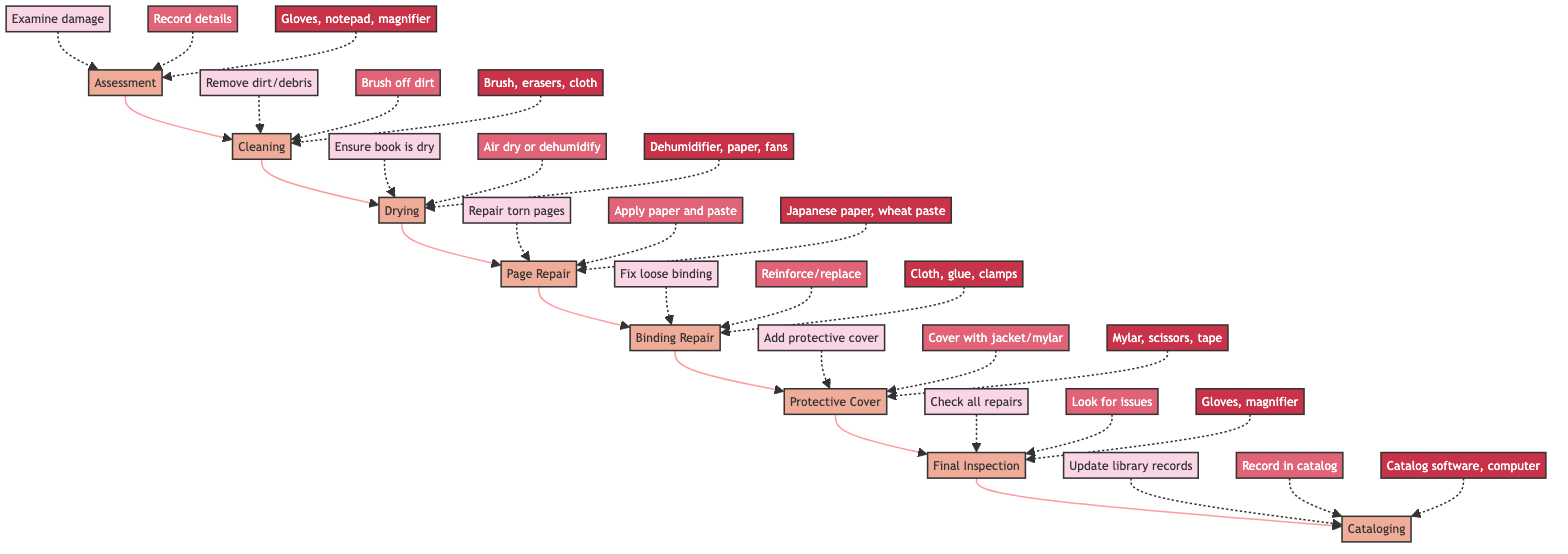What is the first step in the restoration process? The diagram begins with the "Assessment" step at the top, indicating it's the initial phase in restoring a damaged book.
Answer: Assessment How many steps are included in the restoration process? By counting the nodes in the diagram, there are a total of eight distinct steps shown, from "Assessment" to "Cataloging."
Answer: 8 What tools are needed for the 'Page Repair' step? The 'Page Repair' step specifies the tools needed as "Japanese paper, wheat paste, bone folder," which can be found in the corresponding node description.
Answer: Japanese paper, wheat paste, bone folder Which step comes after 'Cleaning'? Looking at the flow from 'Cleaning', the diagram clearly indicates that the next step is 'Drying', following the arrows connecting the steps.
Answer: Drying What action is required in the 'Protective Cover' step? In the 'Protective Cover' node, it states that the action required is to "Cover the book with a new dust jacket or mylar cover," summarizing the needed action at that stage.
Answer: Cover the book with a new dust jacket or mylar cover What is the last step in the restoration process? The final node in the flowchart is "Cataloging," which indicates it is the last step after all repairs and checks are completed.
Answer: Cataloging Which step necessitates the use of a dehumidifier? The 'Drying' step specifically mentions that if the book is damp or wet, one should "Air dry or use a dehumidifier," indicating that this tool is vital for this phase.
Answer: Drying How many tools are listed for the 'Binding Repair' step? Referring to the 'Binding Repair' node, there are three tools listed: "Bookbinding cloth, PVA glue, clamps," indicating the tools necessary for that step.
Answer: 3 What is the purpose of the 'Final Inspection' step? This step requires one to "Examine the restored book to ensure all repairs are satisfactory," clarifying its purpose in ensuring the quality of the restoration.
Answer: Examine the restored book to ensure all repairs are satisfactory 